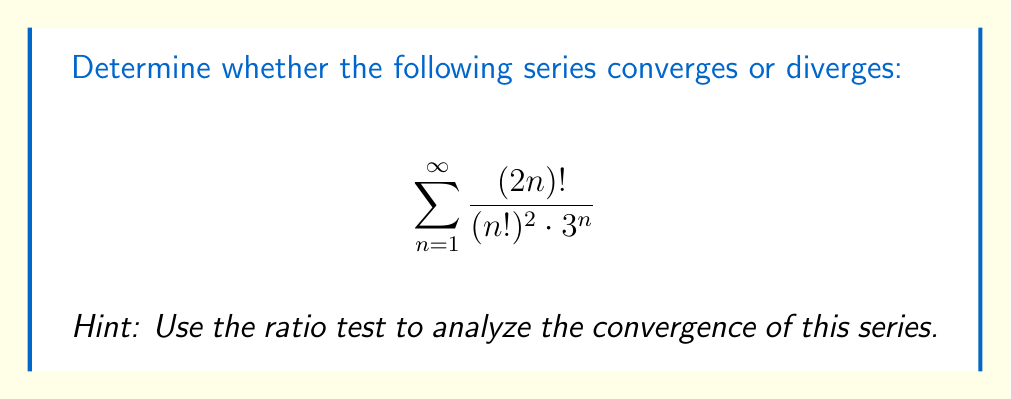Teach me how to tackle this problem. To determine the convergence or divergence of this series using the ratio test, we need to calculate the limit of the ratio of consecutive terms as $n$ approaches infinity.

Let $a_n = \frac{(2n)!}{(n!)^2 \cdot 3^n}$. We need to find $\lim_{n \to \infty} \left|\frac{a_{n+1}}{a_n}\right|$.

Step 1: Express $a_{n+1}$
$$a_{n+1} = \frac{(2n+2)!}{((n+1)!)^2 \cdot 3^{n+1}}$$

Step 2: Calculate the ratio $\frac{a_{n+1}}{a_n}$
$$\begin{align*}
\frac{a_{n+1}}{a_n} &= \frac{(2n+2)!}{((n+1)!)^2 \cdot 3^{n+1}} \cdot \frac{(n!)^2 \cdot 3^n}{(2n)!} \\[10pt]
&= \frac{(2n+2)(2n+1)}{(n+1)^2 \cdot 3} \\[10pt]
&= \frac{4n^2 + 6n + 2}{3n^2 + 6n + 3}
\end{align*}$$

Step 3: Take the limit as $n$ approaches infinity
$$\begin{align*}
\lim_{n \to \infty} \left|\frac{a_{n+1}}{a_n}\right| &= \lim_{n \to \infty} \left|\frac{4n^2 + 6n + 2}{3n^2 + 6n + 3}\right| \\[10pt]
&= \left|\frac{4}{3}\right| \\[10pt]
&= \frac{4}{3}
\end{align*}$$

Step 4: Interpret the result
Since the limit is $\frac{4}{3}$, which is greater than 1, the ratio test concludes that the series diverges.

Remember, for the ratio test:
- If the limit is less than 1, the series converges absolutely.
- If the limit is greater than 1, the series diverges.
- If the limit equals 1, the test is inconclusive.
Answer: The series diverges according to the ratio test, as $\lim_{n \to \infty} \left|\frac{a_{n+1}}{a_n}\right| = \frac{4}{3} > 1$. 